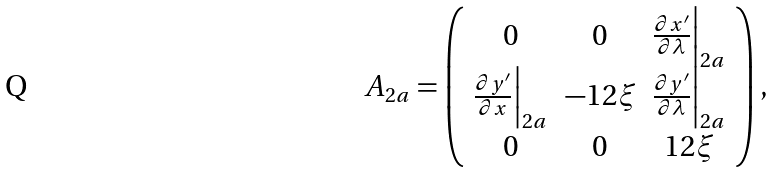<formula> <loc_0><loc_0><loc_500><loc_500>A _ { 2 a } = \left ( \begin{array} { c c c } 0 & 0 & \frac { \partial x ^ { \prime } } { \partial \lambda } \Big | _ { 2 a } \\ \frac { \partial y ^ { \prime } } { \partial x } \Big | _ { 2 a } & - 1 2 \xi & \frac { \partial y ^ { \prime } } { \partial \lambda } \Big | _ { 2 a } \\ 0 & 0 & 1 2 \xi \\ \end{array} \right ) ,</formula> 